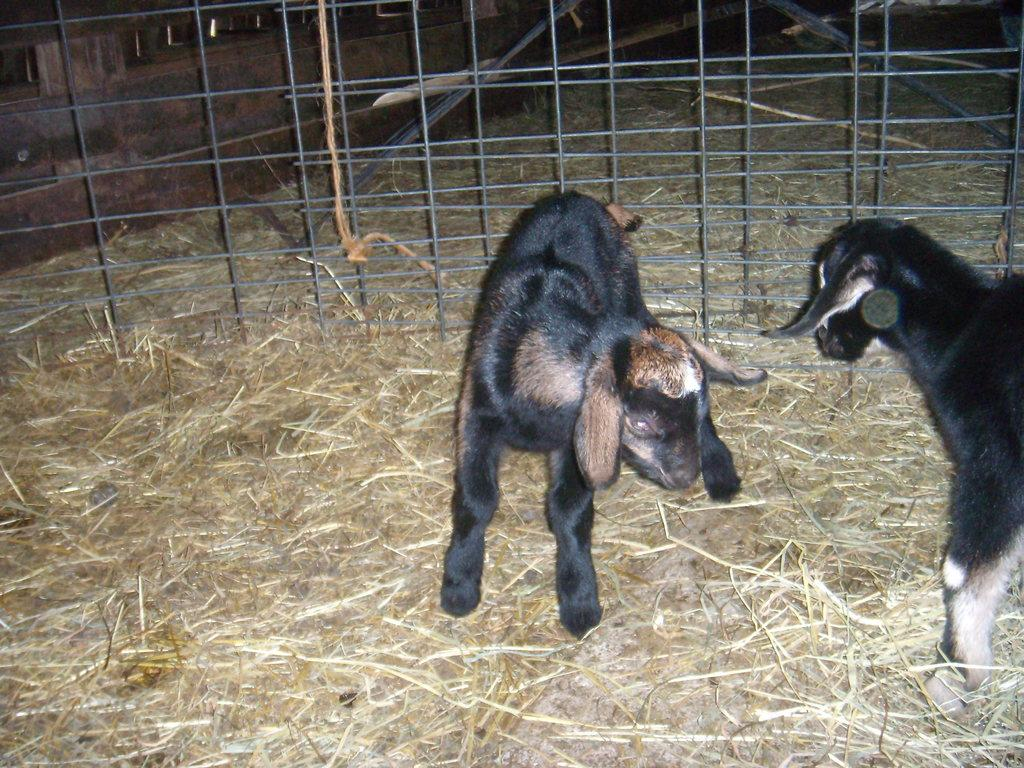What animals are present in the image? There are two baby goats in the image. What is located behind the baby goats? There is metal fencing behind the baby goats. What type of vegetation can be seen on the ground in the image? There is dry grass on the ground in the image. What direction are the baby goats exchanging war strategies in the image? There is no indication of war strategies or any exchange in the image; it features two baby goats and metal fencing behind them. 